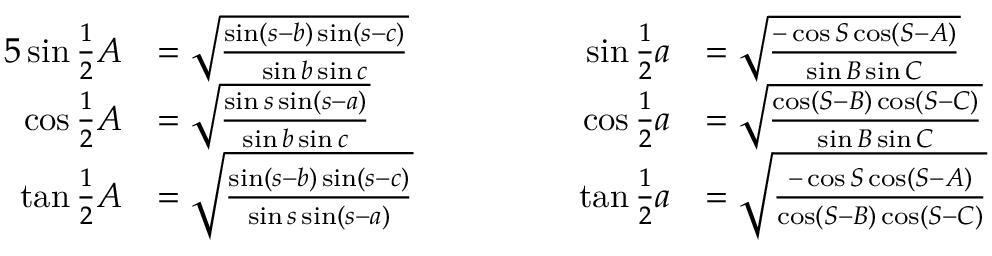Convert formula to latex. <formula><loc_0><loc_0><loc_500><loc_500>{ \begin{array} { r l r l } { { 5 } \sin { \frac { 1 } { 2 } } A } & { = { \sqrt { \frac { \sin ( s - b ) \sin ( s - c ) } { \sin b \sin c } } } } & { \quad \sin { \frac { 1 } { 2 } } a } & { = { \sqrt { \frac { - \cos S \cos ( S - A ) } { \sin B \sin C } } } } \\ { \cos { \frac { 1 } { 2 } } A } & { = { \sqrt { \frac { \sin s \sin ( s - a ) } { \sin b \sin c } } } } & { \cos { \frac { 1 } { 2 } } a } & { = { \sqrt { \frac { \cos ( S - B ) \cos ( S - C ) } { \sin B \sin C } } } } \\ { \tan { \frac { 1 } { 2 } } A } & { = { \sqrt { \frac { \sin ( s - b ) \sin ( s - c ) } { \sin s \sin ( s - a ) } } } } & { \tan { \frac { 1 } { 2 } } a } & { = { \sqrt { \frac { - \cos S \cos ( S - A ) } { \cos ( S - B ) \cos ( S - C ) } } } } \end{array} }</formula> 